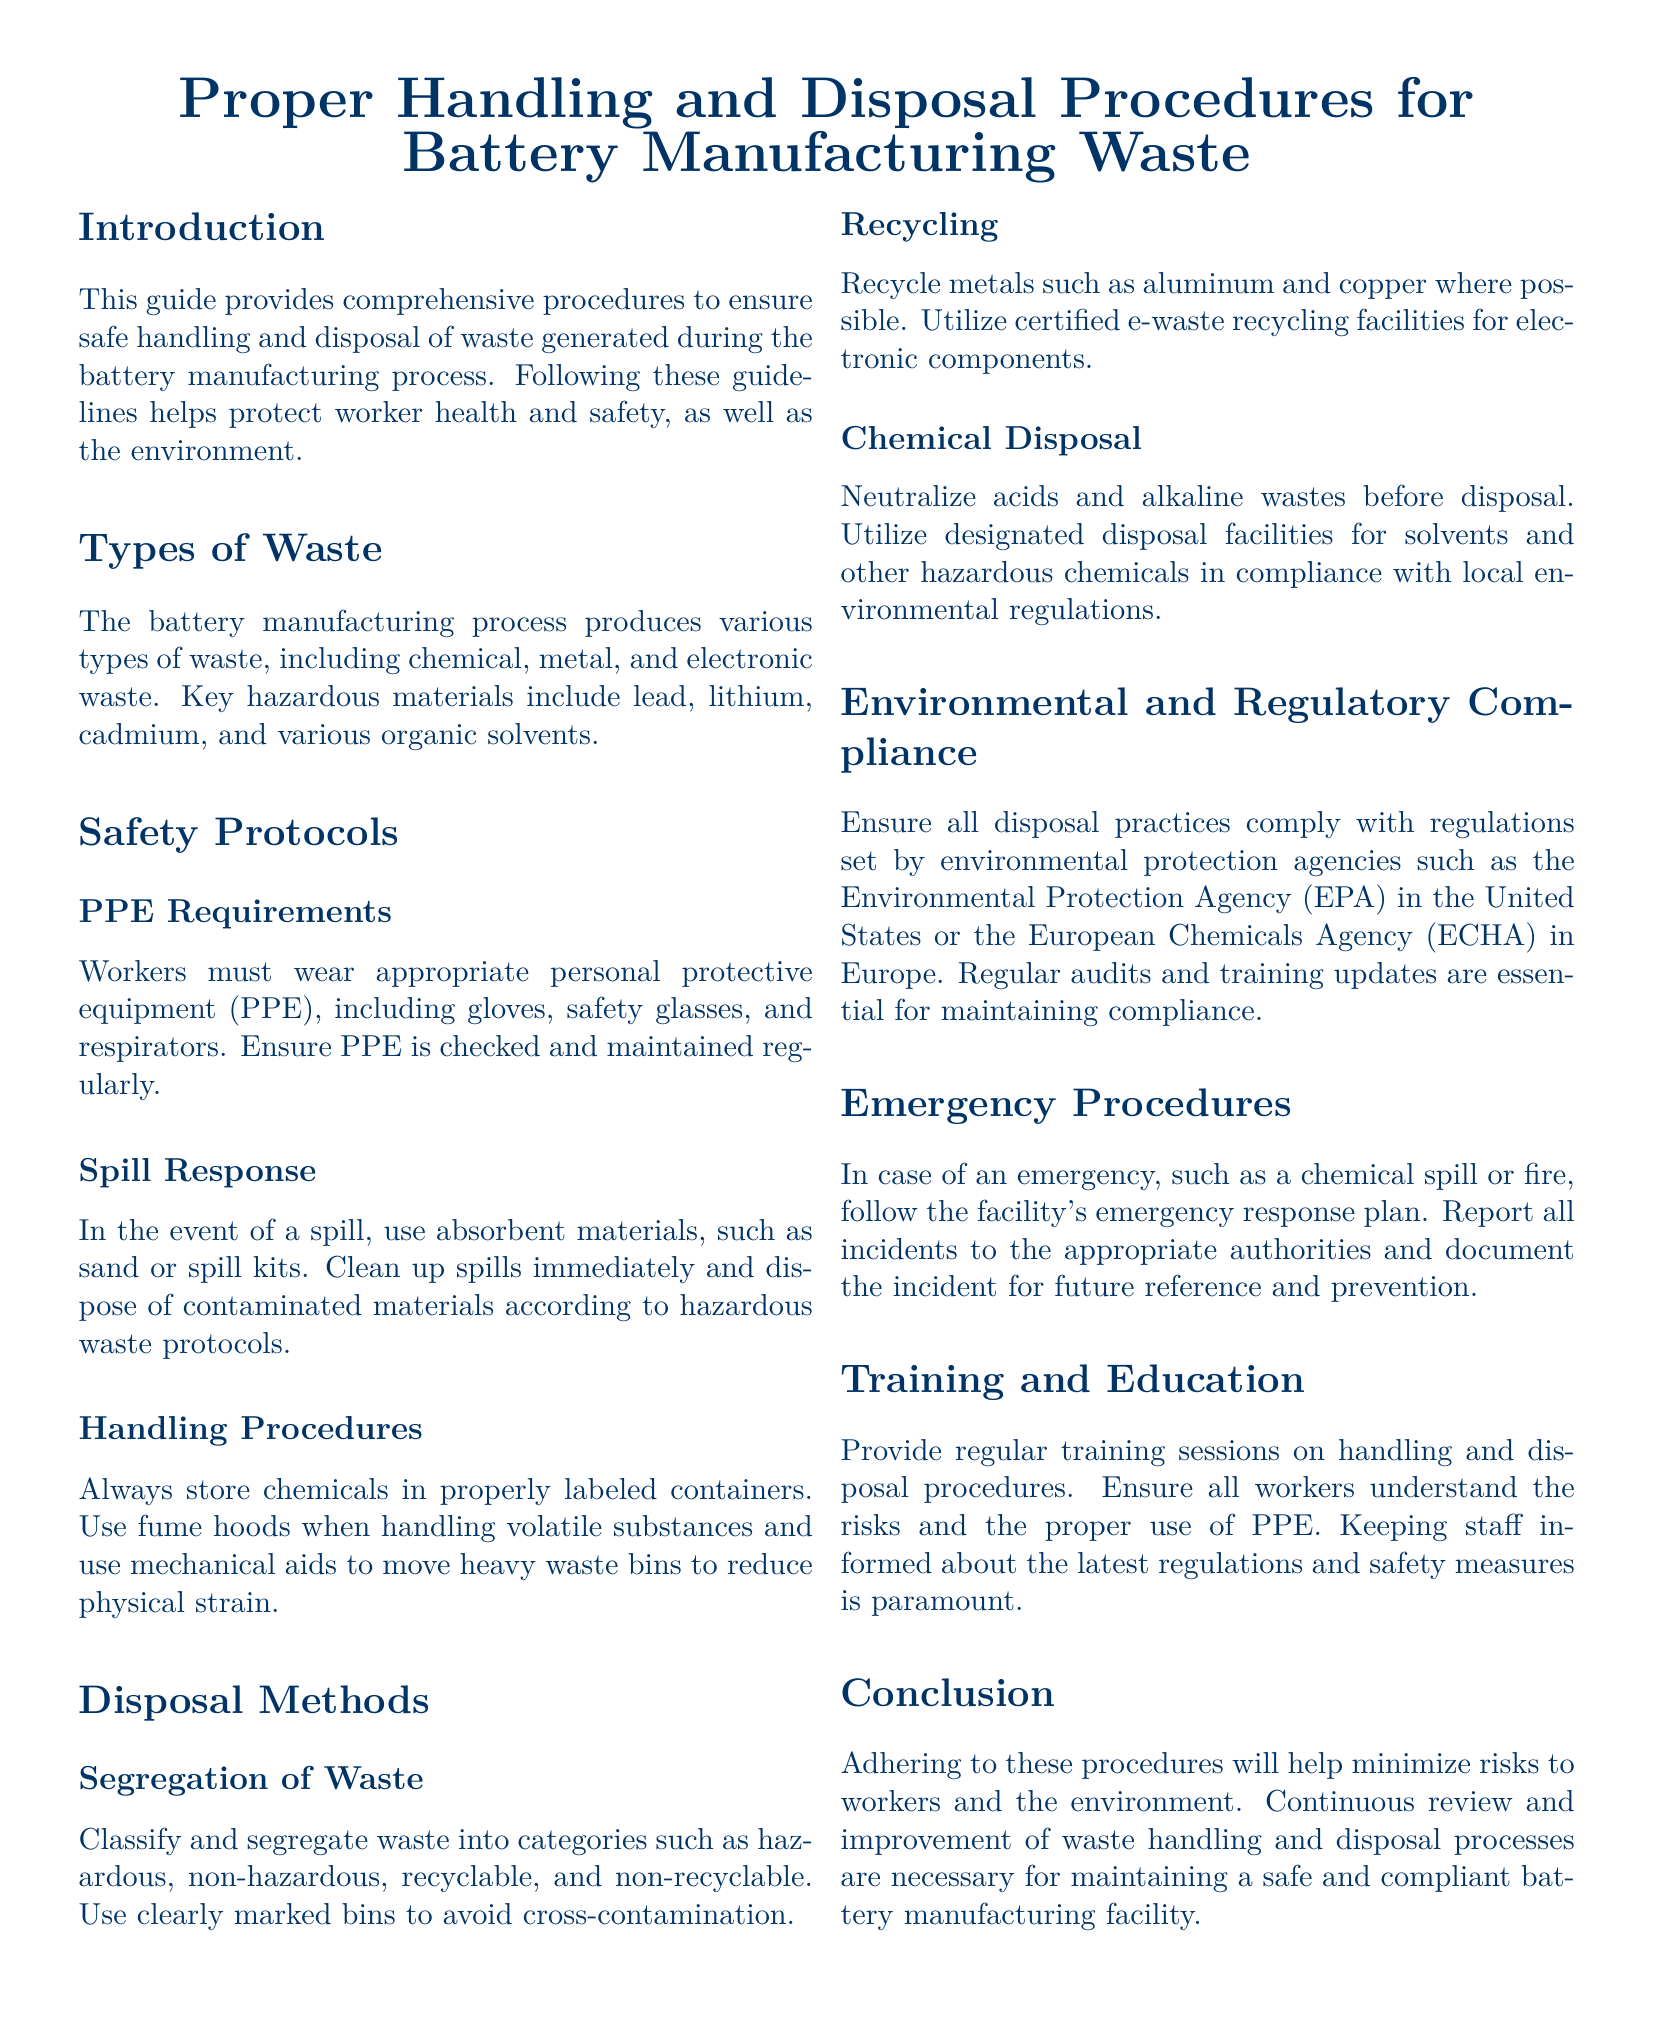What types of waste are produced in battery manufacturing? The document lists various types of waste, including chemical, metal, and electronic waste.
Answer: Chemical, metal, and electronic waste What hazardous materials are mentioned? Hazardous materials listed in the document include lead, lithium, cadmium, and various organic solvents.
Answer: Lead, lithium, cadmium, organic solvents What is required in the event of a spill? The document states to use absorbent materials, such as sand or spill kits, and clean up spills immediately.
Answer: Absorbent materials What must workers wear as PPE? Workers are required to wear gloves, safety glasses, and respirators as stated in the procedures.
Answer: Gloves, safety glasses, respirators How should waste be categorized? Waste should be classified and segregated into categories such as hazardous, non-hazardous, recyclable, and non-recyclable.
Answer: Hazardous, non-hazardous, recyclable, non-recyclable Where should metals like aluminum and copper be sent? The document advises to recycle metals like aluminum and copper where possible.
Answer: Recycle What actions are outlined for chemical disposal? The document outlines that acids and alkaline wastes must be neutralized before disposal.
Answer: Neutralize What should be provided regularly for worker safety? The guide emphasizes the importance of providing regular training sessions on handling and disposal procedures.
Answer: Training sessions What compliance regulations are mentioned? Environmental regulations include those set by agencies like the Environmental Protection Agency (EPA) or the European Chemicals Agency (ECHA).
Answer: EPA, ECHA 